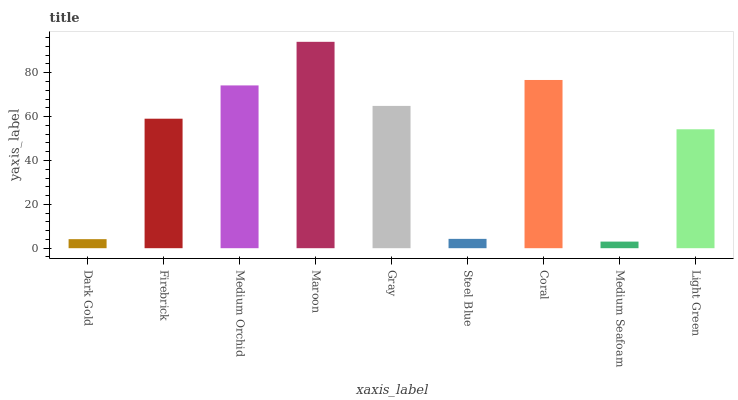Is Firebrick the minimum?
Answer yes or no. No. Is Firebrick the maximum?
Answer yes or no. No. Is Firebrick greater than Dark Gold?
Answer yes or no. Yes. Is Dark Gold less than Firebrick?
Answer yes or no. Yes. Is Dark Gold greater than Firebrick?
Answer yes or no. No. Is Firebrick less than Dark Gold?
Answer yes or no. No. Is Firebrick the high median?
Answer yes or no. Yes. Is Firebrick the low median?
Answer yes or no. Yes. Is Light Green the high median?
Answer yes or no. No. Is Medium Seafoam the low median?
Answer yes or no. No. 